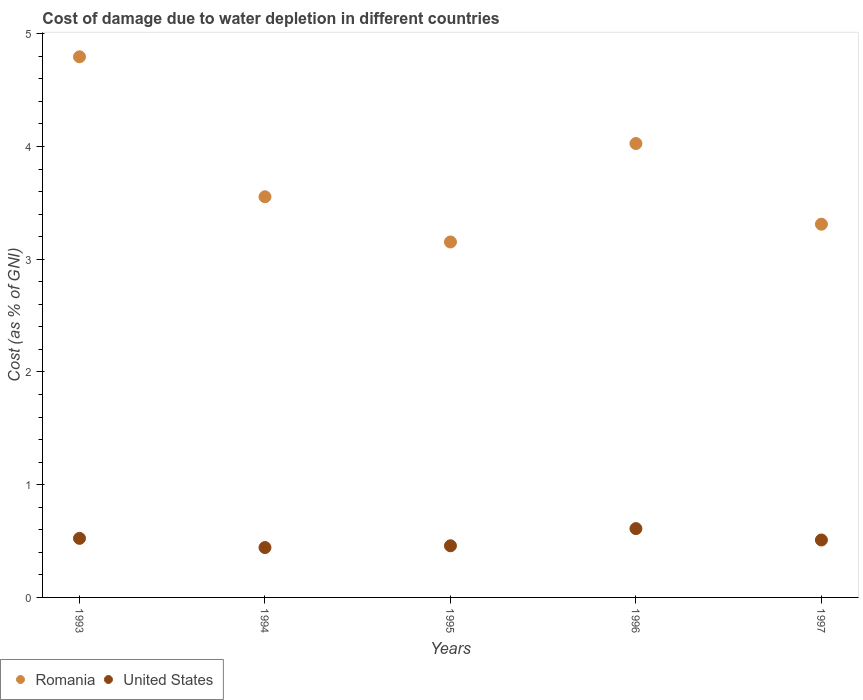How many different coloured dotlines are there?
Offer a terse response. 2. What is the cost of damage caused due to water depletion in Romania in 1993?
Make the answer very short. 4.8. Across all years, what is the maximum cost of damage caused due to water depletion in United States?
Give a very brief answer. 0.61. Across all years, what is the minimum cost of damage caused due to water depletion in Romania?
Your answer should be compact. 3.15. In which year was the cost of damage caused due to water depletion in United States maximum?
Give a very brief answer. 1996. What is the total cost of damage caused due to water depletion in Romania in the graph?
Your response must be concise. 18.84. What is the difference between the cost of damage caused due to water depletion in United States in 1995 and that in 1997?
Give a very brief answer. -0.05. What is the difference between the cost of damage caused due to water depletion in United States in 1997 and the cost of damage caused due to water depletion in Romania in 1995?
Offer a very short reply. -2.64. What is the average cost of damage caused due to water depletion in Romania per year?
Provide a short and direct response. 3.77. In the year 1997, what is the difference between the cost of damage caused due to water depletion in United States and cost of damage caused due to water depletion in Romania?
Provide a succinct answer. -2.8. In how many years, is the cost of damage caused due to water depletion in United States greater than 2 %?
Give a very brief answer. 0. What is the ratio of the cost of damage caused due to water depletion in Romania in 1995 to that in 1997?
Keep it short and to the point. 0.95. Is the cost of damage caused due to water depletion in Romania in 1993 less than that in 1994?
Offer a very short reply. No. What is the difference between the highest and the second highest cost of damage caused due to water depletion in United States?
Keep it short and to the point. 0.09. What is the difference between the highest and the lowest cost of damage caused due to water depletion in Romania?
Your answer should be compact. 1.64. In how many years, is the cost of damage caused due to water depletion in Romania greater than the average cost of damage caused due to water depletion in Romania taken over all years?
Offer a very short reply. 2. Is the sum of the cost of damage caused due to water depletion in Romania in 1993 and 1997 greater than the maximum cost of damage caused due to water depletion in United States across all years?
Ensure brevity in your answer.  Yes. Is the cost of damage caused due to water depletion in Romania strictly less than the cost of damage caused due to water depletion in United States over the years?
Offer a very short reply. No. How many dotlines are there?
Keep it short and to the point. 2. Are the values on the major ticks of Y-axis written in scientific E-notation?
Ensure brevity in your answer.  No. Does the graph contain grids?
Ensure brevity in your answer.  No. Where does the legend appear in the graph?
Your answer should be very brief. Bottom left. What is the title of the graph?
Provide a short and direct response. Cost of damage due to water depletion in different countries. Does "Solomon Islands" appear as one of the legend labels in the graph?
Your response must be concise. No. What is the label or title of the X-axis?
Provide a succinct answer. Years. What is the label or title of the Y-axis?
Your answer should be compact. Cost (as % of GNI). What is the Cost (as % of GNI) of Romania in 1993?
Your response must be concise. 4.8. What is the Cost (as % of GNI) of United States in 1993?
Offer a terse response. 0.52. What is the Cost (as % of GNI) of Romania in 1994?
Your answer should be compact. 3.55. What is the Cost (as % of GNI) in United States in 1994?
Offer a terse response. 0.44. What is the Cost (as % of GNI) of Romania in 1995?
Your answer should be compact. 3.15. What is the Cost (as % of GNI) of United States in 1995?
Provide a short and direct response. 0.46. What is the Cost (as % of GNI) in Romania in 1996?
Offer a terse response. 4.03. What is the Cost (as % of GNI) in United States in 1996?
Give a very brief answer. 0.61. What is the Cost (as % of GNI) of Romania in 1997?
Your answer should be very brief. 3.31. What is the Cost (as % of GNI) in United States in 1997?
Keep it short and to the point. 0.51. Across all years, what is the maximum Cost (as % of GNI) in Romania?
Provide a succinct answer. 4.8. Across all years, what is the maximum Cost (as % of GNI) in United States?
Make the answer very short. 0.61. Across all years, what is the minimum Cost (as % of GNI) of Romania?
Keep it short and to the point. 3.15. Across all years, what is the minimum Cost (as % of GNI) of United States?
Offer a terse response. 0.44. What is the total Cost (as % of GNI) of Romania in the graph?
Offer a very short reply. 18.84. What is the total Cost (as % of GNI) of United States in the graph?
Your answer should be very brief. 2.54. What is the difference between the Cost (as % of GNI) of Romania in 1993 and that in 1994?
Provide a succinct answer. 1.24. What is the difference between the Cost (as % of GNI) in United States in 1993 and that in 1994?
Ensure brevity in your answer.  0.08. What is the difference between the Cost (as % of GNI) of Romania in 1993 and that in 1995?
Offer a very short reply. 1.64. What is the difference between the Cost (as % of GNI) of United States in 1993 and that in 1995?
Ensure brevity in your answer.  0.07. What is the difference between the Cost (as % of GNI) of Romania in 1993 and that in 1996?
Offer a terse response. 0.77. What is the difference between the Cost (as % of GNI) of United States in 1993 and that in 1996?
Your answer should be very brief. -0.09. What is the difference between the Cost (as % of GNI) of Romania in 1993 and that in 1997?
Keep it short and to the point. 1.49. What is the difference between the Cost (as % of GNI) of United States in 1993 and that in 1997?
Your answer should be very brief. 0.01. What is the difference between the Cost (as % of GNI) of Romania in 1994 and that in 1995?
Keep it short and to the point. 0.4. What is the difference between the Cost (as % of GNI) of United States in 1994 and that in 1995?
Offer a terse response. -0.02. What is the difference between the Cost (as % of GNI) in Romania in 1994 and that in 1996?
Keep it short and to the point. -0.47. What is the difference between the Cost (as % of GNI) in United States in 1994 and that in 1996?
Ensure brevity in your answer.  -0.17. What is the difference between the Cost (as % of GNI) in Romania in 1994 and that in 1997?
Keep it short and to the point. 0.24. What is the difference between the Cost (as % of GNI) in United States in 1994 and that in 1997?
Offer a very short reply. -0.07. What is the difference between the Cost (as % of GNI) in Romania in 1995 and that in 1996?
Your answer should be compact. -0.87. What is the difference between the Cost (as % of GNI) of United States in 1995 and that in 1996?
Your answer should be very brief. -0.15. What is the difference between the Cost (as % of GNI) of Romania in 1995 and that in 1997?
Give a very brief answer. -0.16. What is the difference between the Cost (as % of GNI) in United States in 1995 and that in 1997?
Keep it short and to the point. -0.05. What is the difference between the Cost (as % of GNI) in Romania in 1996 and that in 1997?
Provide a succinct answer. 0.72. What is the difference between the Cost (as % of GNI) in United States in 1996 and that in 1997?
Your answer should be very brief. 0.1. What is the difference between the Cost (as % of GNI) of Romania in 1993 and the Cost (as % of GNI) of United States in 1994?
Your answer should be very brief. 4.35. What is the difference between the Cost (as % of GNI) of Romania in 1993 and the Cost (as % of GNI) of United States in 1995?
Provide a short and direct response. 4.34. What is the difference between the Cost (as % of GNI) in Romania in 1993 and the Cost (as % of GNI) in United States in 1996?
Offer a very short reply. 4.19. What is the difference between the Cost (as % of GNI) of Romania in 1993 and the Cost (as % of GNI) of United States in 1997?
Your answer should be compact. 4.29. What is the difference between the Cost (as % of GNI) in Romania in 1994 and the Cost (as % of GNI) in United States in 1995?
Your answer should be very brief. 3.1. What is the difference between the Cost (as % of GNI) of Romania in 1994 and the Cost (as % of GNI) of United States in 1996?
Your response must be concise. 2.94. What is the difference between the Cost (as % of GNI) in Romania in 1994 and the Cost (as % of GNI) in United States in 1997?
Keep it short and to the point. 3.04. What is the difference between the Cost (as % of GNI) of Romania in 1995 and the Cost (as % of GNI) of United States in 1996?
Ensure brevity in your answer.  2.54. What is the difference between the Cost (as % of GNI) of Romania in 1995 and the Cost (as % of GNI) of United States in 1997?
Your answer should be compact. 2.64. What is the difference between the Cost (as % of GNI) in Romania in 1996 and the Cost (as % of GNI) in United States in 1997?
Your response must be concise. 3.52. What is the average Cost (as % of GNI) in Romania per year?
Make the answer very short. 3.77. What is the average Cost (as % of GNI) of United States per year?
Offer a very short reply. 0.51. In the year 1993, what is the difference between the Cost (as % of GNI) in Romania and Cost (as % of GNI) in United States?
Provide a short and direct response. 4.27. In the year 1994, what is the difference between the Cost (as % of GNI) in Romania and Cost (as % of GNI) in United States?
Offer a very short reply. 3.11. In the year 1995, what is the difference between the Cost (as % of GNI) in Romania and Cost (as % of GNI) in United States?
Ensure brevity in your answer.  2.69. In the year 1996, what is the difference between the Cost (as % of GNI) of Romania and Cost (as % of GNI) of United States?
Your answer should be compact. 3.42. In the year 1997, what is the difference between the Cost (as % of GNI) of Romania and Cost (as % of GNI) of United States?
Offer a very short reply. 2.8. What is the ratio of the Cost (as % of GNI) in Romania in 1993 to that in 1994?
Make the answer very short. 1.35. What is the ratio of the Cost (as % of GNI) in United States in 1993 to that in 1994?
Keep it short and to the point. 1.18. What is the ratio of the Cost (as % of GNI) of Romania in 1993 to that in 1995?
Offer a very short reply. 1.52. What is the ratio of the Cost (as % of GNI) of United States in 1993 to that in 1995?
Your answer should be very brief. 1.14. What is the ratio of the Cost (as % of GNI) of Romania in 1993 to that in 1996?
Offer a very short reply. 1.19. What is the ratio of the Cost (as % of GNI) in United States in 1993 to that in 1996?
Your answer should be compact. 0.86. What is the ratio of the Cost (as % of GNI) of Romania in 1993 to that in 1997?
Your answer should be compact. 1.45. What is the ratio of the Cost (as % of GNI) of United States in 1993 to that in 1997?
Provide a short and direct response. 1.03. What is the ratio of the Cost (as % of GNI) of Romania in 1994 to that in 1995?
Provide a short and direct response. 1.13. What is the ratio of the Cost (as % of GNI) of United States in 1994 to that in 1995?
Your response must be concise. 0.97. What is the ratio of the Cost (as % of GNI) in Romania in 1994 to that in 1996?
Provide a short and direct response. 0.88. What is the ratio of the Cost (as % of GNI) of United States in 1994 to that in 1996?
Provide a succinct answer. 0.72. What is the ratio of the Cost (as % of GNI) of Romania in 1994 to that in 1997?
Offer a terse response. 1.07. What is the ratio of the Cost (as % of GNI) in United States in 1994 to that in 1997?
Ensure brevity in your answer.  0.87. What is the ratio of the Cost (as % of GNI) in Romania in 1995 to that in 1996?
Make the answer very short. 0.78. What is the ratio of the Cost (as % of GNI) in United States in 1995 to that in 1996?
Provide a succinct answer. 0.75. What is the ratio of the Cost (as % of GNI) of United States in 1995 to that in 1997?
Make the answer very short. 0.9. What is the ratio of the Cost (as % of GNI) of Romania in 1996 to that in 1997?
Your response must be concise. 1.22. What is the ratio of the Cost (as % of GNI) in United States in 1996 to that in 1997?
Make the answer very short. 1.2. What is the difference between the highest and the second highest Cost (as % of GNI) in Romania?
Keep it short and to the point. 0.77. What is the difference between the highest and the second highest Cost (as % of GNI) of United States?
Give a very brief answer. 0.09. What is the difference between the highest and the lowest Cost (as % of GNI) in Romania?
Your answer should be compact. 1.64. What is the difference between the highest and the lowest Cost (as % of GNI) in United States?
Give a very brief answer. 0.17. 